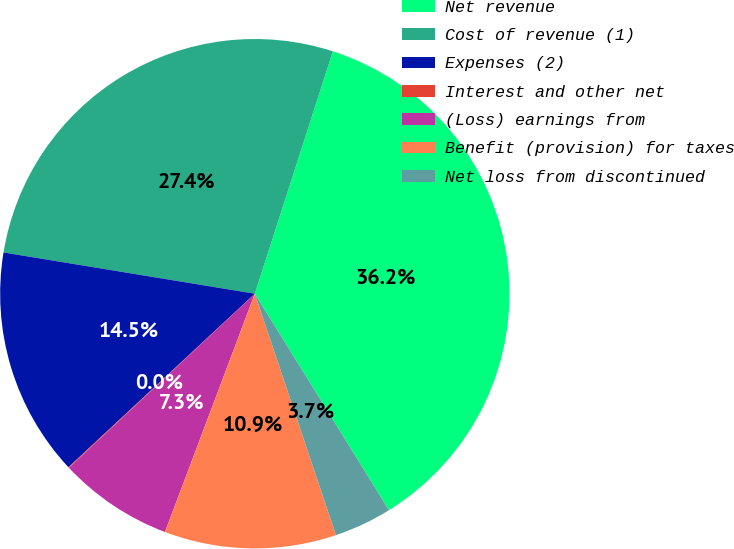<chart> <loc_0><loc_0><loc_500><loc_500><pie_chart><fcel>Net revenue<fcel>Cost of revenue (1)<fcel>Expenses (2)<fcel>Interest and other net<fcel>(Loss) earnings from<fcel>Benefit (provision) for taxes<fcel>Net loss from discontinued<nl><fcel>36.21%<fcel>27.37%<fcel>14.52%<fcel>0.05%<fcel>7.28%<fcel>10.9%<fcel>3.67%<nl></chart> 